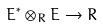<formula> <loc_0><loc_0><loc_500><loc_500>E ^ { * } \otimes _ { R } E \rightarrow R</formula> 